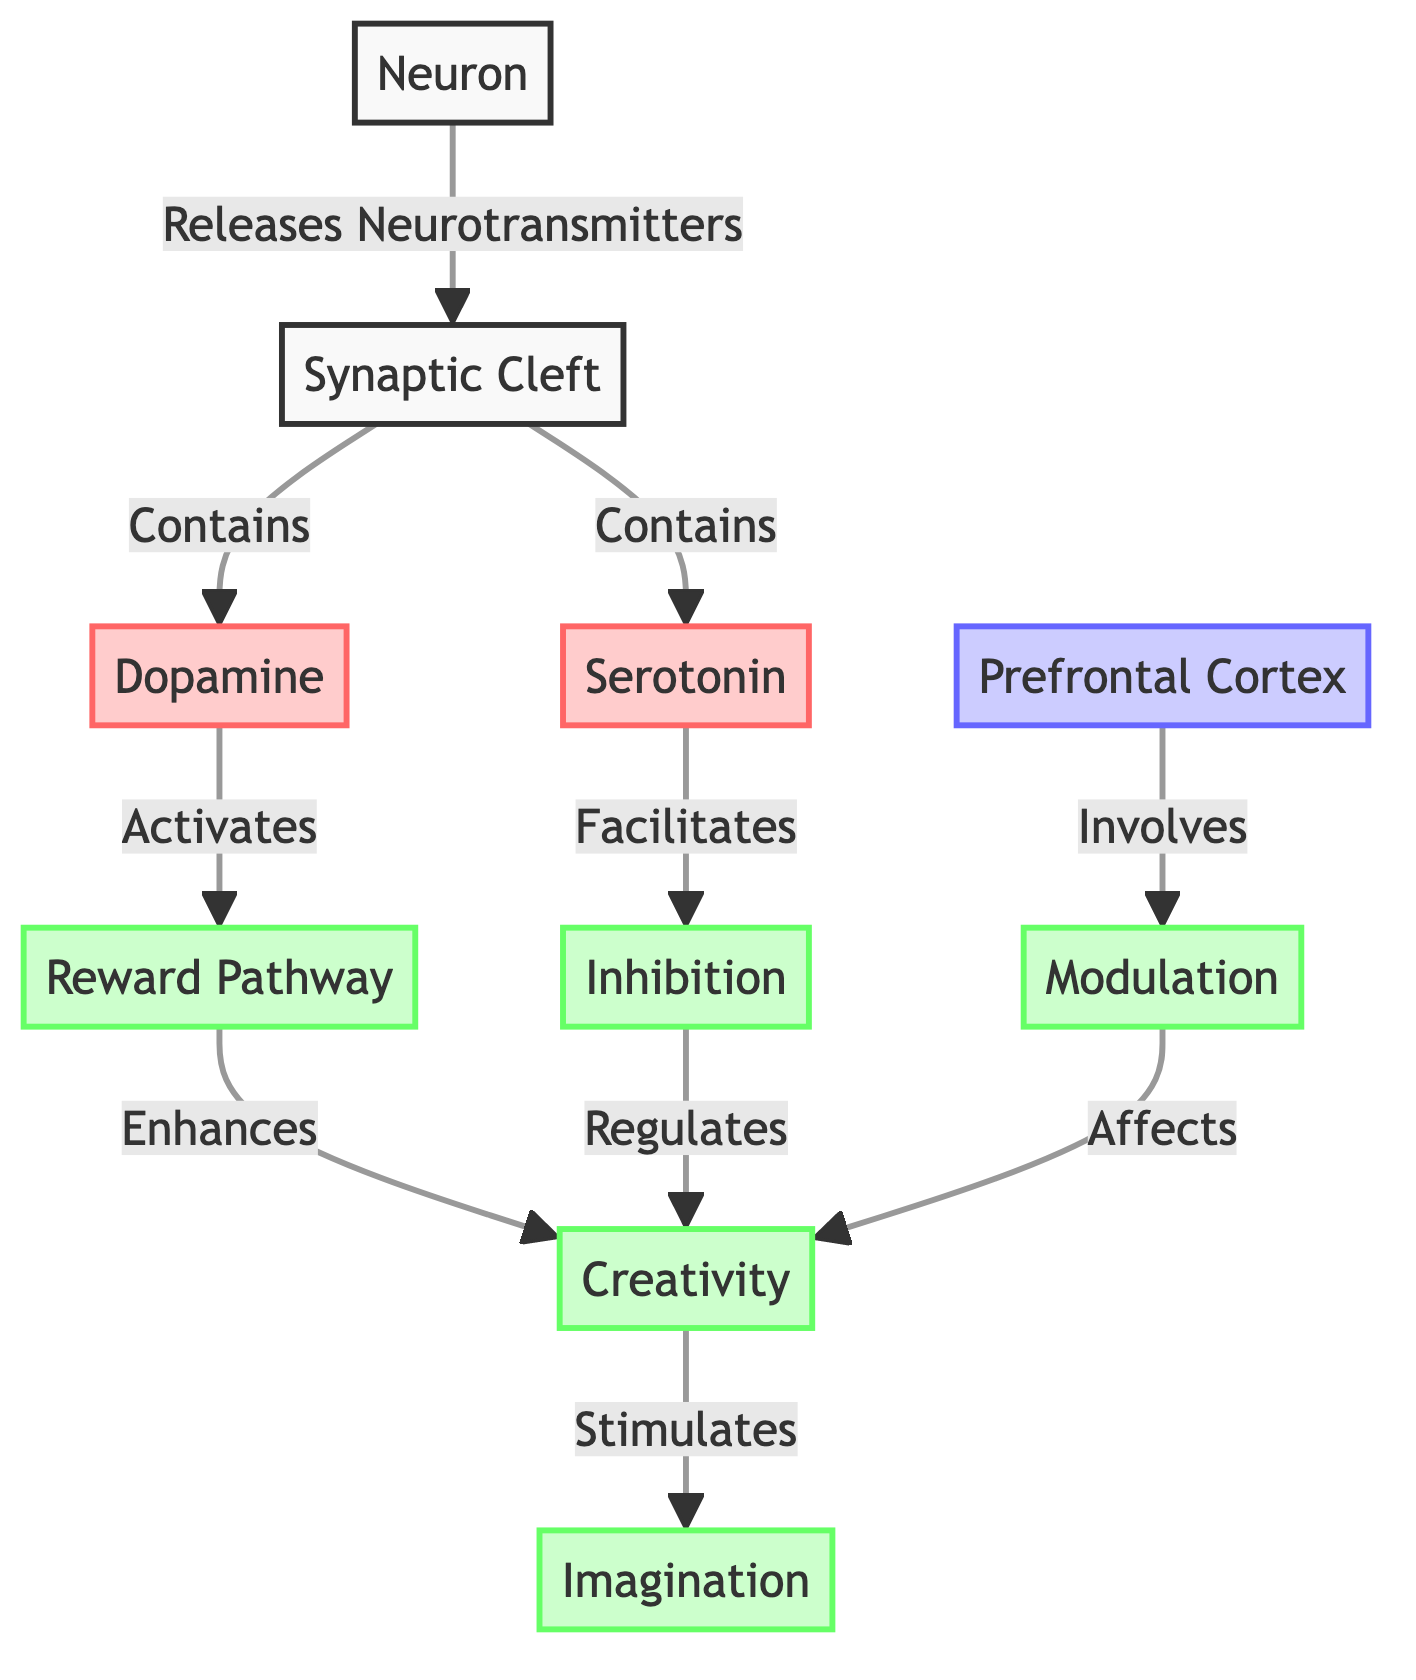What neurotransmitter is activated by dopamine in the reward pathway? The diagram indicates that dopamine activates the reward pathway. Therefore, the neurotransmitter involved in this specific relationship is dopamine itself.
Answer: Dopamine How many processes are influenced by serotonin? The diagram shows that serotonin facilitates inhibition, and inhibition regulates creativity. Thus, there are two processes influenced by serotonin: inhibition and creativity.
Answer: Two What is the role of the prefrontal cortex in the diagram? The diagram states that the prefrontal cortex involves modulation, indicating that its role is to modulate related activities or processes.
Answer: Modulation Which process is stimulated directly by creativity? According to the diagram, creativity stimulates imagination directly. Thus, the process that is stimulated by creativity is imagination.
Answer: Imagination What is the relationship between the reward pathway and creativity? The diagram specifies that the reward pathway enhances creativity. Therefore, the relationship is that enhancement describes how the reward pathway affects creativity.
Answer: Enhances How many nodes are listed as neurotransmitters in the diagram? The diagram lists two neurotransmitters: dopamine and serotonin. Hence, there are two nodes that are classified as neurotransmitters.
Answer: Two What does inhibition regulate in the diagram? Based on the diagram, inhibition regulates creativity. Thus, the regulation pertains specifically to the process of creativity.
Answer: Creativity Which part of the diagram involves modulation? The prefrontal cortex is specified in the diagram as involving modulation. Therefore, the part that includes modulation is the prefrontal cortex.
Answer: Prefrontal Cortex 